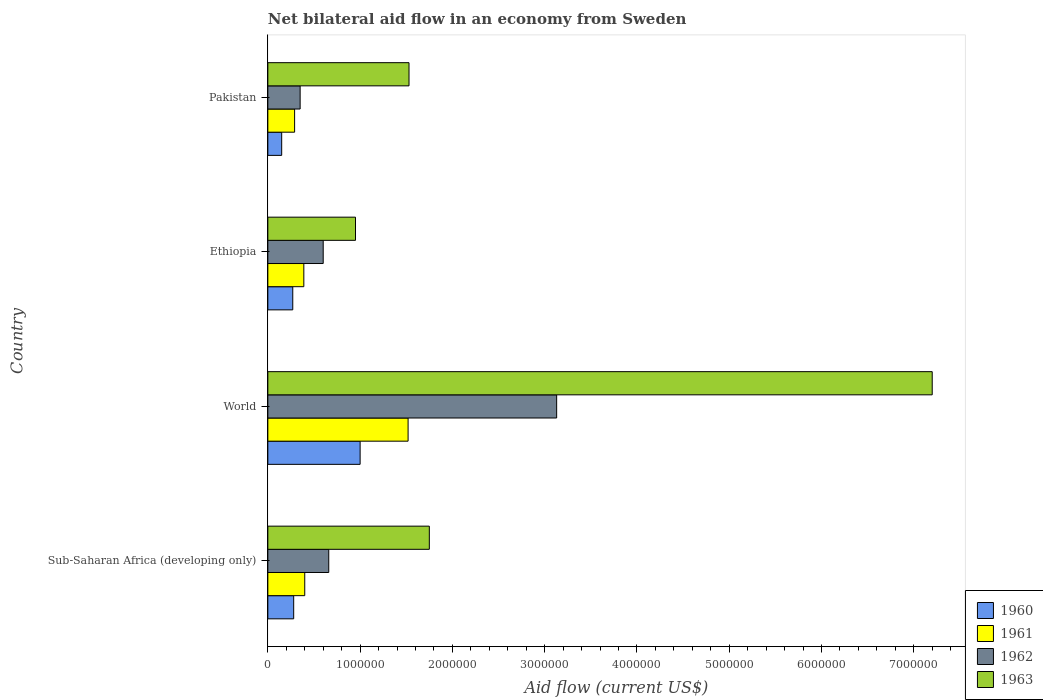How many groups of bars are there?
Your answer should be very brief. 4. Are the number of bars on each tick of the Y-axis equal?
Your answer should be very brief. Yes. What is the net bilateral aid flow in 1962 in World?
Provide a succinct answer. 3.13e+06. Across all countries, what is the maximum net bilateral aid flow in 1963?
Give a very brief answer. 7.20e+06. In which country was the net bilateral aid flow in 1962 maximum?
Offer a terse response. World. What is the total net bilateral aid flow in 1962 in the graph?
Offer a terse response. 4.74e+06. What is the difference between the net bilateral aid flow in 1963 in Ethiopia and that in World?
Offer a terse response. -6.25e+06. What is the difference between the net bilateral aid flow in 1962 in Ethiopia and the net bilateral aid flow in 1963 in Pakistan?
Offer a terse response. -9.30e+05. What is the average net bilateral aid flow in 1963 per country?
Offer a very short reply. 2.86e+06. What is the difference between the net bilateral aid flow in 1961 and net bilateral aid flow in 1960 in Pakistan?
Offer a terse response. 1.40e+05. What is the ratio of the net bilateral aid flow in 1962 in Ethiopia to that in Pakistan?
Your answer should be compact. 1.71. Is the net bilateral aid flow in 1963 in Pakistan less than that in Sub-Saharan Africa (developing only)?
Provide a succinct answer. Yes. Is the difference between the net bilateral aid flow in 1961 in Ethiopia and Pakistan greater than the difference between the net bilateral aid flow in 1960 in Ethiopia and Pakistan?
Offer a terse response. No. What is the difference between the highest and the second highest net bilateral aid flow in 1962?
Your answer should be very brief. 2.47e+06. What is the difference between the highest and the lowest net bilateral aid flow in 1963?
Provide a short and direct response. 6.25e+06. Is it the case that in every country, the sum of the net bilateral aid flow in 1960 and net bilateral aid flow in 1963 is greater than the sum of net bilateral aid flow in 1962 and net bilateral aid flow in 1961?
Your response must be concise. Yes. How many bars are there?
Keep it short and to the point. 16. How many countries are there in the graph?
Give a very brief answer. 4. What is the difference between two consecutive major ticks on the X-axis?
Give a very brief answer. 1.00e+06. Are the values on the major ticks of X-axis written in scientific E-notation?
Provide a short and direct response. No. Does the graph contain any zero values?
Give a very brief answer. No. Where does the legend appear in the graph?
Offer a very short reply. Bottom right. How many legend labels are there?
Provide a short and direct response. 4. How are the legend labels stacked?
Give a very brief answer. Vertical. What is the title of the graph?
Your response must be concise. Net bilateral aid flow in an economy from Sweden. What is the Aid flow (current US$) of 1960 in Sub-Saharan Africa (developing only)?
Your response must be concise. 2.80e+05. What is the Aid flow (current US$) of 1961 in Sub-Saharan Africa (developing only)?
Provide a short and direct response. 4.00e+05. What is the Aid flow (current US$) in 1962 in Sub-Saharan Africa (developing only)?
Your response must be concise. 6.60e+05. What is the Aid flow (current US$) in 1963 in Sub-Saharan Africa (developing only)?
Your answer should be compact. 1.75e+06. What is the Aid flow (current US$) in 1961 in World?
Make the answer very short. 1.52e+06. What is the Aid flow (current US$) of 1962 in World?
Your response must be concise. 3.13e+06. What is the Aid flow (current US$) in 1963 in World?
Make the answer very short. 7.20e+06. What is the Aid flow (current US$) of 1963 in Ethiopia?
Keep it short and to the point. 9.50e+05. What is the Aid flow (current US$) in 1960 in Pakistan?
Provide a short and direct response. 1.50e+05. What is the Aid flow (current US$) in 1962 in Pakistan?
Give a very brief answer. 3.50e+05. What is the Aid flow (current US$) in 1963 in Pakistan?
Give a very brief answer. 1.53e+06. Across all countries, what is the maximum Aid flow (current US$) of 1961?
Make the answer very short. 1.52e+06. Across all countries, what is the maximum Aid flow (current US$) of 1962?
Your response must be concise. 3.13e+06. Across all countries, what is the maximum Aid flow (current US$) in 1963?
Your answer should be very brief. 7.20e+06. Across all countries, what is the minimum Aid flow (current US$) of 1961?
Make the answer very short. 2.90e+05. Across all countries, what is the minimum Aid flow (current US$) in 1962?
Your answer should be compact. 3.50e+05. Across all countries, what is the minimum Aid flow (current US$) in 1963?
Make the answer very short. 9.50e+05. What is the total Aid flow (current US$) of 1960 in the graph?
Make the answer very short. 1.70e+06. What is the total Aid flow (current US$) of 1961 in the graph?
Offer a terse response. 2.60e+06. What is the total Aid flow (current US$) of 1962 in the graph?
Ensure brevity in your answer.  4.74e+06. What is the total Aid flow (current US$) of 1963 in the graph?
Offer a terse response. 1.14e+07. What is the difference between the Aid flow (current US$) in 1960 in Sub-Saharan Africa (developing only) and that in World?
Give a very brief answer. -7.20e+05. What is the difference between the Aid flow (current US$) of 1961 in Sub-Saharan Africa (developing only) and that in World?
Offer a terse response. -1.12e+06. What is the difference between the Aid flow (current US$) of 1962 in Sub-Saharan Africa (developing only) and that in World?
Your answer should be compact. -2.47e+06. What is the difference between the Aid flow (current US$) of 1963 in Sub-Saharan Africa (developing only) and that in World?
Offer a terse response. -5.45e+06. What is the difference between the Aid flow (current US$) of 1960 in Sub-Saharan Africa (developing only) and that in Ethiopia?
Provide a short and direct response. 10000. What is the difference between the Aid flow (current US$) of 1962 in Sub-Saharan Africa (developing only) and that in Ethiopia?
Your answer should be compact. 6.00e+04. What is the difference between the Aid flow (current US$) of 1963 in Sub-Saharan Africa (developing only) and that in Ethiopia?
Provide a short and direct response. 8.00e+05. What is the difference between the Aid flow (current US$) in 1961 in Sub-Saharan Africa (developing only) and that in Pakistan?
Your response must be concise. 1.10e+05. What is the difference between the Aid flow (current US$) of 1960 in World and that in Ethiopia?
Keep it short and to the point. 7.30e+05. What is the difference between the Aid flow (current US$) of 1961 in World and that in Ethiopia?
Keep it short and to the point. 1.13e+06. What is the difference between the Aid flow (current US$) of 1962 in World and that in Ethiopia?
Offer a very short reply. 2.53e+06. What is the difference between the Aid flow (current US$) of 1963 in World and that in Ethiopia?
Give a very brief answer. 6.25e+06. What is the difference between the Aid flow (current US$) of 1960 in World and that in Pakistan?
Offer a terse response. 8.50e+05. What is the difference between the Aid flow (current US$) in 1961 in World and that in Pakistan?
Make the answer very short. 1.23e+06. What is the difference between the Aid flow (current US$) of 1962 in World and that in Pakistan?
Make the answer very short. 2.78e+06. What is the difference between the Aid flow (current US$) in 1963 in World and that in Pakistan?
Make the answer very short. 5.67e+06. What is the difference between the Aid flow (current US$) of 1961 in Ethiopia and that in Pakistan?
Ensure brevity in your answer.  1.00e+05. What is the difference between the Aid flow (current US$) in 1963 in Ethiopia and that in Pakistan?
Ensure brevity in your answer.  -5.80e+05. What is the difference between the Aid flow (current US$) in 1960 in Sub-Saharan Africa (developing only) and the Aid flow (current US$) in 1961 in World?
Give a very brief answer. -1.24e+06. What is the difference between the Aid flow (current US$) of 1960 in Sub-Saharan Africa (developing only) and the Aid flow (current US$) of 1962 in World?
Give a very brief answer. -2.85e+06. What is the difference between the Aid flow (current US$) in 1960 in Sub-Saharan Africa (developing only) and the Aid flow (current US$) in 1963 in World?
Provide a succinct answer. -6.92e+06. What is the difference between the Aid flow (current US$) of 1961 in Sub-Saharan Africa (developing only) and the Aid flow (current US$) of 1962 in World?
Provide a succinct answer. -2.73e+06. What is the difference between the Aid flow (current US$) in 1961 in Sub-Saharan Africa (developing only) and the Aid flow (current US$) in 1963 in World?
Your answer should be compact. -6.80e+06. What is the difference between the Aid flow (current US$) in 1962 in Sub-Saharan Africa (developing only) and the Aid flow (current US$) in 1963 in World?
Make the answer very short. -6.54e+06. What is the difference between the Aid flow (current US$) of 1960 in Sub-Saharan Africa (developing only) and the Aid flow (current US$) of 1962 in Ethiopia?
Keep it short and to the point. -3.20e+05. What is the difference between the Aid flow (current US$) of 1960 in Sub-Saharan Africa (developing only) and the Aid flow (current US$) of 1963 in Ethiopia?
Provide a short and direct response. -6.70e+05. What is the difference between the Aid flow (current US$) in 1961 in Sub-Saharan Africa (developing only) and the Aid flow (current US$) in 1962 in Ethiopia?
Offer a terse response. -2.00e+05. What is the difference between the Aid flow (current US$) in 1961 in Sub-Saharan Africa (developing only) and the Aid flow (current US$) in 1963 in Ethiopia?
Provide a short and direct response. -5.50e+05. What is the difference between the Aid flow (current US$) of 1960 in Sub-Saharan Africa (developing only) and the Aid flow (current US$) of 1962 in Pakistan?
Your response must be concise. -7.00e+04. What is the difference between the Aid flow (current US$) in 1960 in Sub-Saharan Africa (developing only) and the Aid flow (current US$) in 1963 in Pakistan?
Your response must be concise. -1.25e+06. What is the difference between the Aid flow (current US$) of 1961 in Sub-Saharan Africa (developing only) and the Aid flow (current US$) of 1963 in Pakistan?
Offer a terse response. -1.13e+06. What is the difference between the Aid flow (current US$) of 1962 in Sub-Saharan Africa (developing only) and the Aid flow (current US$) of 1963 in Pakistan?
Provide a short and direct response. -8.70e+05. What is the difference between the Aid flow (current US$) in 1960 in World and the Aid flow (current US$) in 1963 in Ethiopia?
Offer a very short reply. 5.00e+04. What is the difference between the Aid flow (current US$) of 1961 in World and the Aid flow (current US$) of 1962 in Ethiopia?
Provide a succinct answer. 9.20e+05. What is the difference between the Aid flow (current US$) in 1961 in World and the Aid flow (current US$) in 1963 in Ethiopia?
Your answer should be compact. 5.70e+05. What is the difference between the Aid flow (current US$) in 1962 in World and the Aid flow (current US$) in 1963 in Ethiopia?
Ensure brevity in your answer.  2.18e+06. What is the difference between the Aid flow (current US$) in 1960 in World and the Aid flow (current US$) in 1961 in Pakistan?
Offer a terse response. 7.10e+05. What is the difference between the Aid flow (current US$) of 1960 in World and the Aid flow (current US$) of 1962 in Pakistan?
Offer a very short reply. 6.50e+05. What is the difference between the Aid flow (current US$) of 1960 in World and the Aid flow (current US$) of 1963 in Pakistan?
Give a very brief answer. -5.30e+05. What is the difference between the Aid flow (current US$) of 1961 in World and the Aid flow (current US$) of 1962 in Pakistan?
Offer a terse response. 1.17e+06. What is the difference between the Aid flow (current US$) in 1961 in World and the Aid flow (current US$) in 1963 in Pakistan?
Offer a very short reply. -10000. What is the difference between the Aid flow (current US$) in 1962 in World and the Aid flow (current US$) in 1963 in Pakistan?
Give a very brief answer. 1.60e+06. What is the difference between the Aid flow (current US$) of 1960 in Ethiopia and the Aid flow (current US$) of 1961 in Pakistan?
Ensure brevity in your answer.  -2.00e+04. What is the difference between the Aid flow (current US$) in 1960 in Ethiopia and the Aid flow (current US$) in 1963 in Pakistan?
Your answer should be compact. -1.26e+06. What is the difference between the Aid flow (current US$) of 1961 in Ethiopia and the Aid flow (current US$) of 1962 in Pakistan?
Your answer should be compact. 4.00e+04. What is the difference between the Aid flow (current US$) in 1961 in Ethiopia and the Aid flow (current US$) in 1963 in Pakistan?
Your answer should be very brief. -1.14e+06. What is the difference between the Aid flow (current US$) of 1962 in Ethiopia and the Aid flow (current US$) of 1963 in Pakistan?
Your answer should be compact. -9.30e+05. What is the average Aid flow (current US$) of 1960 per country?
Your response must be concise. 4.25e+05. What is the average Aid flow (current US$) in 1961 per country?
Ensure brevity in your answer.  6.50e+05. What is the average Aid flow (current US$) of 1962 per country?
Your response must be concise. 1.18e+06. What is the average Aid flow (current US$) in 1963 per country?
Offer a terse response. 2.86e+06. What is the difference between the Aid flow (current US$) in 1960 and Aid flow (current US$) in 1961 in Sub-Saharan Africa (developing only)?
Offer a terse response. -1.20e+05. What is the difference between the Aid flow (current US$) in 1960 and Aid flow (current US$) in 1962 in Sub-Saharan Africa (developing only)?
Make the answer very short. -3.80e+05. What is the difference between the Aid flow (current US$) in 1960 and Aid flow (current US$) in 1963 in Sub-Saharan Africa (developing only)?
Your answer should be very brief. -1.47e+06. What is the difference between the Aid flow (current US$) of 1961 and Aid flow (current US$) of 1963 in Sub-Saharan Africa (developing only)?
Provide a succinct answer. -1.35e+06. What is the difference between the Aid flow (current US$) in 1962 and Aid flow (current US$) in 1963 in Sub-Saharan Africa (developing only)?
Offer a very short reply. -1.09e+06. What is the difference between the Aid flow (current US$) in 1960 and Aid flow (current US$) in 1961 in World?
Keep it short and to the point. -5.20e+05. What is the difference between the Aid flow (current US$) of 1960 and Aid flow (current US$) of 1962 in World?
Offer a very short reply. -2.13e+06. What is the difference between the Aid flow (current US$) of 1960 and Aid flow (current US$) of 1963 in World?
Give a very brief answer. -6.20e+06. What is the difference between the Aid flow (current US$) of 1961 and Aid flow (current US$) of 1962 in World?
Make the answer very short. -1.61e+06. What is the difference between the Aid flow (current US$) of 1961 and Aid flow (current US$) of 1963 in World?
Provide a succinct answer. -5.68e+06. What is the difference between the Aid flow (current US$) in 1962 and Aid flow (current US$) in 1963 in World?
Provide a succinct answer. -4.07e+06. What is the difference between the Aid flow (current US$) of 1960 and Aid flow (current US$) of 1962 in Ethiopia?
Your response must be concise. -3.30e+05. What is the difference between the Aid flow (current US$) of 1960 and Aid flow (current US$) of 1963 in Ethiopia?
Give a very brief answer. -6.80e+05. What is the difference between the Aid flow (current US$) of 1961 and Aid flow (current US$) of 1962 in Ethiopia?
Make the answer very short. -2.10e+05. What is the difference between the Aid flow (current US$) in 1961 and Aid flow (current US$) in 1963 in Ethiopia?
Provide a succinct answer. -5.60e+05. What is the difference between the Aid flow (current US$) in 1962 and Aid flow (current US$) in 1963 in Ethiopia?
Make the answer very short. -3.50e+05. What is the difference between the Aid flow (current US$) of 1960 and Aid flow (current US$) of 1961 in Pakistan?
Give a very brief answer. -1.40e+05. What is the difference between the Aid flow (current US$) in 1960 and Aid flow (current US$) in 1962 in Pakistan?
Keep it short and to the point. -2.00e+05. What is the difference between the Aid flow (current US$) in 1960 and Aid flow (current US$) in 1963 in Pakistan?
Offer a very short reply. -1.38e+06. What is the difference between the Aid flow (current US$) in 1961 and Aid flow (current US$) in 1962 in Pakistan?
Your response must be concise. -6.00e+04. What is the difference between the Aid flow (current US$) of 1961 and Aid flow (current US$) of 1963 in Pakistan?
Your response must be concise. -1.24e+06. What is the difference between the Aid flow (current US$) of 1962 and Aid flow (current US$) of 1963 in Pakistan?
Ensure brevity in your answer.  -1.18e+06. What is the ratio of the Aid flow (current US$) in 1960 in Sub-Saharan Africa (developing only) to that in World?
Ensure brevity in your answer.  0.28. What is the ratio of the Aid flow (current US$) in 1961 in Sub-Saharan Africa (developing only) to that in World?
Provide a succinct answer. 0.26. What is the ratio of the Aid flow (current US$) in 1962 in Sub-Saharan Africa (developing only) to that in World?
Offer a very short reply. 0.21. What is the ratio of the Aid flow (current US$) in 1963 in Sub-Saharan Africa (developing only) to that in World?
Keep it short and to the point. 0.24. What is the ratio of the Aid flow (current US$) of 1960 in Sub-Saharan Africa (developing only) to that in Ethiopia?
Give a very brief answer. 1.04. What is the ratio of the Aid flow (current US$) of 1961 in Sub-Saharan Africa (developing only) to that in Ethiopia?
Provide a short and direct response. 1.03. What is the ratio of the Aid flow (current US$) in 1962 in Sub-Saharan Africa (developing only) to that in Ethiopia?
Offer a terse response. 1.1. What is the ratio of the Aid flow (current US$) of 1963 in Sub-Saharan Africa (developing only) to that in Ethiopia?
Make the answer very short. 1.84. What is the ratio of the Aid flow (current US$) of 1960 in Sub-Saharan Africa (developing only) to that in Pakistan?
Make the answer very short. 1.87. What is the ratio of the Aid flow (current US$) of 1961 in Sub-Saharan Africa (developing only) to that in Pakistan?
Offer a terse response. 1.38. What is the ratio of the Aid flow (current US$) in 1962 in Sub-Saharan Africa (developing only) to that in Pakistan?
Your answer should be very brief. 1.89. What is the ratio of the Aid flow (current US$) in 1963 in Sub-Saharan Africa (developing only) to that in Pakistan?
Make the answer very short. 1.14. What is the ratio of the Aid flow (current US$) of 1960 in World to that in Ethiopia?
Make the answer very short. 3.7. What is the ratio of the Aid flow (current US$) of 1961 in World to that in Ethiopia?
Offer a very short reply. 3.9. What is the ratio of the Aid flow (current US$) in 1962 in World to that in Ethiopia?
Ensure brevity in your answer.  5.22. What is the ratio of the Aid flow (current US$) of 1963 in World to that in Ethiopia?
Keep it short and to the point. 7.58. What is the ratio of the Aid flow (current US$) in 1960 in World to that in Pakistan?
Your response must be concise. 6.67. What is the ratio of the Aid flow (current US$) of 1961 in World to that in Pakistan?
Offer a terse response. 5.24. What is the ratio of the Aid flow (current US$) of 1962 in World to that in Pakistan?
Keep it short and to the point. 8.94. What is the ratio of the Aid flow (current US$) of 1963 in World to that in Pakistan?
Provide a short and direct response. 4.71. What is the ratio of the Aid flow (current US$) in 1961 in Ethiopia to that in Pakistan?
Offer a very short reply. 1.34. What is the ratio of the Aid flow (current US$) of 1962 in Ethiopia to that in Pakistan?
Your answer should be very brief. 1.71. What is the ratio of the Aid flow (current US$) in 1963 in Ethiopia to that in Pakistan?
Your answer should be very brief. 0.62. What is the difference between the highest and the second highest Aid flow (current US$) of 1960?
Your answer should be very brief. 7.20e+05. What is the difference between the highest and the second highest Aid flow (current US$) of 1961?
Ensure brevity in your answer.  1.12e+06. What is the difference between the highest and the second highest Aid flow (current US$) of 1962?
Give a very brief answer. 2.47e+06. What is the difference between the highest and the second highest Aid flow (current US$) in 1963?
Offer a very short reply. 5.45e+06. What is the difference between the highest and the lowest Aid flow (current US$) in 1960?
Your answer should be compact. 8.50e+05. What is the difference between the highest and the lowest Aid flow (current US$) in 1961?
Make the answer very short. 1.23e+06. What is the difference between the highest and the lowest Aid flow (current US$) in 1962?
Provide a succinct answer. 2.78e+06. What is the difference between the highest and the lowest Aid flow (current US$) in 1963?
Your answer should be very brief. 6.25e+06. 